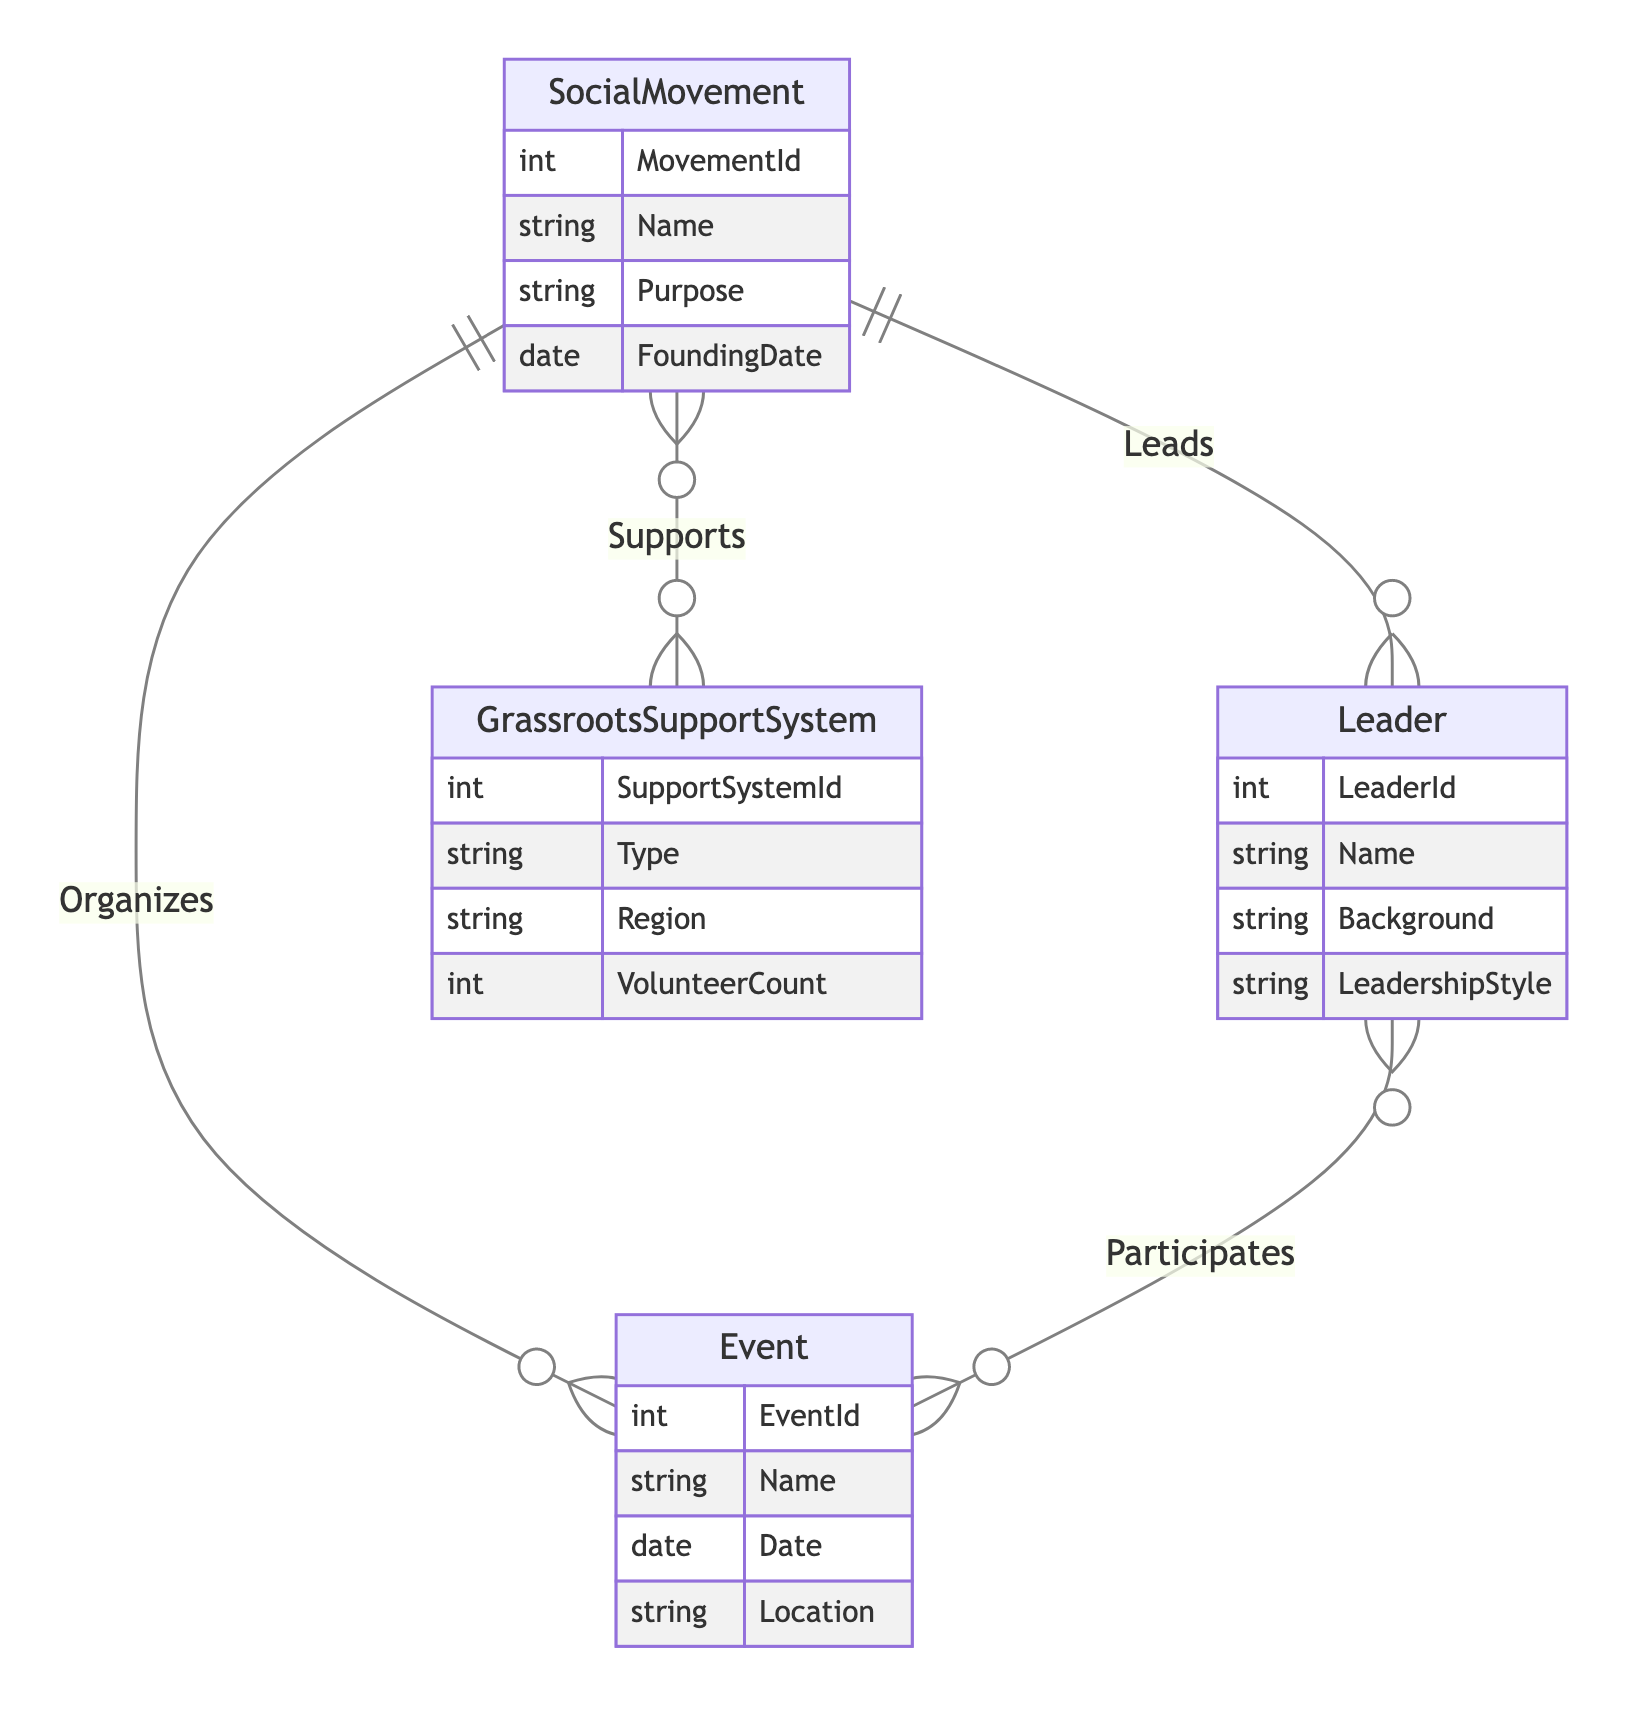What is the maximum number of leaders for a single social movement? The relationship "Leads" between "Leader" and "SocialMovement" has a cardinality of "1:M", meaning one leader can lead multiple social movements. Therefore, the maximum is theoretically unlimited, but the diagram does not specify a number.
Answer: unlimited How many attributes does the 'GrassrootsSupportSystem' entity have? The 'GrassrootsSupportSystem' entity lists four attributes: SupportSystemId, Type, Region, and VolunteerCount. Thus, the count of attributes is simply counted from the entity’s definition.
Answer: 4 Which entity is involved in the 'Organizes' relationship? The 'Organizes' relationship is between the 'SocialMovement' and 'Event' entities. By directly looking at the relationships defined in the diagram, this can be identified clearly.
Answer: SocialMovement, Event What type of relationship is "Supports" and what is its cardinality? The relationship "Supports" connects the 'GrassrootsSupportSystem' and 'SocialMovement' entities and has a cardinality of "M:N". This means multiple grassroots systems can support multiple social movements.
Answer: M:N How many entities are there in total in the diagram? There are four entities in total: SocialMovement, Leader, GrassrootsSupportSystem, and Event. Counting these gives the total number of distinct entities presented in the diagram.
Answer: 4 Which entity can participate in multiple events? The 'Leader' entity can participate in multiple events according to the "Participates" relationship that has a cardinality of "M:N". This indicates leaders can be involved in multiple events and vice versa.
Answer: Leader What is the founding date attribute of the 'SocialMovement'? The 'SocialMovement' entity includes an attribute named FoundingDate, which specifically refers to the date the movement was established. The attribute’s name is directly pulled from the entity's definition shown in the diagram.
Answer: FoundingDate How many grassroot support systems can support a single social movement? The "Supports" relationship has a cardinality of "M:N", meaning multiple grassroots support systems can support one social movement. The exact number isn't specified, but it indicates that many systems can support one movement.
Answer: many What characteristic distinguishes the "Leads" relationship? The "Leads" relationship is characterized as "1:M", which means one leader can lead multiple social movements, distinguishing it from other relationships which are M:N. This indicates the hierarchical structure of leadership in movements.
Answer: 1:M 